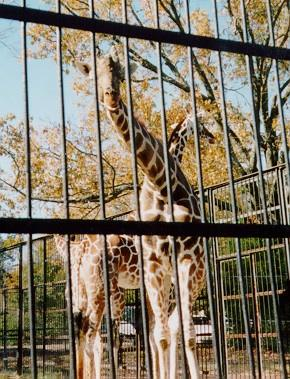What is between the is the fence made of? metal 